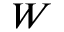Convert formula to latex. <formula><loc_0><loc_0><loc_500><loc_500>W</formula> 